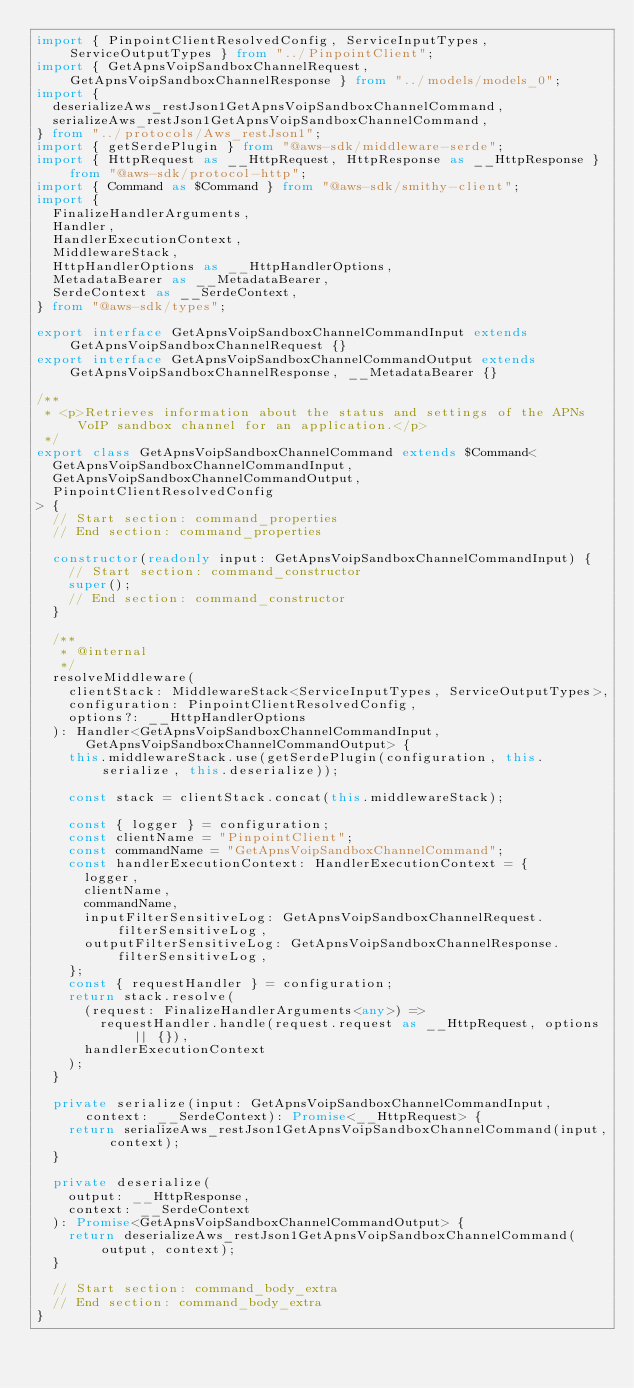<code> <loc_0><loc_0><loc_500><loc_500><_TypeScript_>import { PinpointClientResolvedConfig, ServiceInputTypes, ServiceOutputTypes } from "../PinpointClient";
import { GetApnsVoipSandboxChannelRequest, GetApnsVoipSandboxChannelResponse } from "../models/models_0";
import {
  deserializeAws_restJson1GetApnsVoipSandboxChannelCommand,
  serializeAws_restJson1GetApnsVoipSandboxChannelCommand,
} from "../protocols/Aws_restJson1";
import { getSerdePlugin } from "@aws-sdk/middleware-serde";
import { HttpRequest as __HttpRequest, HttpResponse as __HttpResponse } from "@aws-sdk/protocol-http";
import { Command as $Command } from "@aws-sdk/smithy-client";
import {
  FinalizeHandlerArguments,
  Handler,
  HandlerExecutionContext,
  MiddlewareStack,
  HttpHandlerOptions as __HttpHandlerOptions,
  MetadataBearer as __MetadataBearer,
  SerdeContext as __SerdeContext,
} from "@aws-sdk/types";

export interface GetApnsVoipSandboxChannelCommandInput extends GetApnsVoipSandboxChannelRequest {}
export interface GetApnsVoipSandboxChannelCommandOutput extends GetApnsVoipSandboxChannelResponse, __MetadataBearer {}

/**
 * <p>Retrieves information about the status and settings of the APNs VoIP sandbox channel for an application.</p>
 */
export class GetApnsVoipSandboxChannelCommand extends $Command<
  GetApnsVoipSandboxChannelCommandInput,
  GetApnsVoipSandboxChannelCommandOutput,
  PinpointClientResolvedConfig
> {
  // Start section: command_properties
  // End section: command_properties

  constructor(readonly input: GetApnsVoipSandboxChannelCommandInput) {
    // Start section: command_constructor
    super();
    // End section: command_constructor
  }

  /**
   * @internal
   */
  resolveMiddleware(
    clientStack: MiddlewareStack<ServiceInputTypes, ServiceOutputTypes>,
    configuration: PinpointClientResolvedConfig,
    options?: __HttpHandlerOptions
  ): Handler<GetApnsVoipSandboxChannelCommandInput, GetApnsVoipSandboxChannelCommandOutput> {
    this.middlewareStack.use(getSerdePlugin(configuration, this.serialize, this.deserialize));

    const stack = clientStack.concat(this.middlewareStack);

    const { logger } = configuration;
    const clientName = "PinpointClient";
    const commandName = "GetApnsVoipSandboxChannelCommand";
    const handlerExecutionContext: HandlerExecutionContext = {
      logger,
      clientName,
      commandName,
      inputFilterSensitiveLog: GetApnsVoipSandboxChannelRequest.filterSensitiveLog,
      outputFilterSensitiveLog: GetApnsVoipSandboxChannelResponse.filterSensitiveLog,
    };
    const { requestHandler } = configuration;
    return stack.resolve(
      (request: FinalizeHandlerArguments<any>) =>
        requestHandler.handle(request.request as __HttpRequest, options || {}),
      handlerExecutionContext
    );
  }

  private serialize(input: GetApnsVoipSandboxChannelCommandInput, context: __SerdeContext): Promise<__HttpRequest> {
    return serializeAws_restJson1GetApnsVoipSandboxChannelCommand(input, context);
  }

  private deserialize(
    output: __HttpResponse,
    context: __SerdeContext
  ): Promise<GetApnsVoipSandboxChannelCommandOutput> {
    return deserializeAws_restJson1GetApnsVoipSandboxChannelCommand(output, context);
  }

  // Start section: command_body_extra
  // End section: command_body_extra
}
</code> 